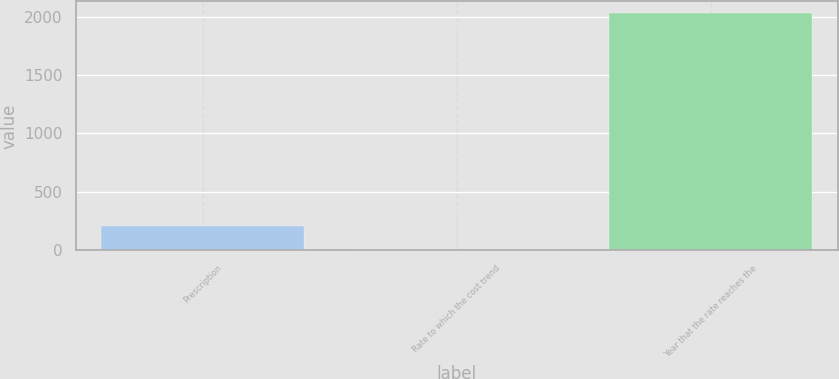<chart> <loc_0><loc_0><loc_500><loc_500><bar_chart><fcel>Prescription<fcel>Rate to which the cost trend<fcel>Year that the rate reaches the<nl><fcel>206.95<fcel>4.5<fcel>2029<nl></chart> 